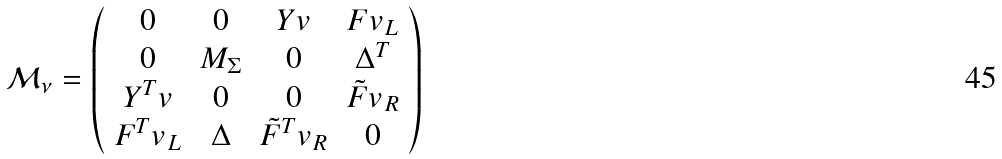Convert formula to latex. <formula><loc_0><loc_0><loc_500><loc_500>\mathcal { M _ { \nu } } = \left ( \begin{array} { c c c c } 0 & 0 & Y v & F v _ { L } \\ 0 & M _ { \Sigma } & 0 & \Delta ^ { T } \\ Y ^ { T } v & 0 & 0 & \tilde { F } v _ { R } \\ F ^ { T } v _ { L } & \Delta & \tilde { F } ^ { T } v _ { R } & 0 \\ \end{array} \right )</formula> 